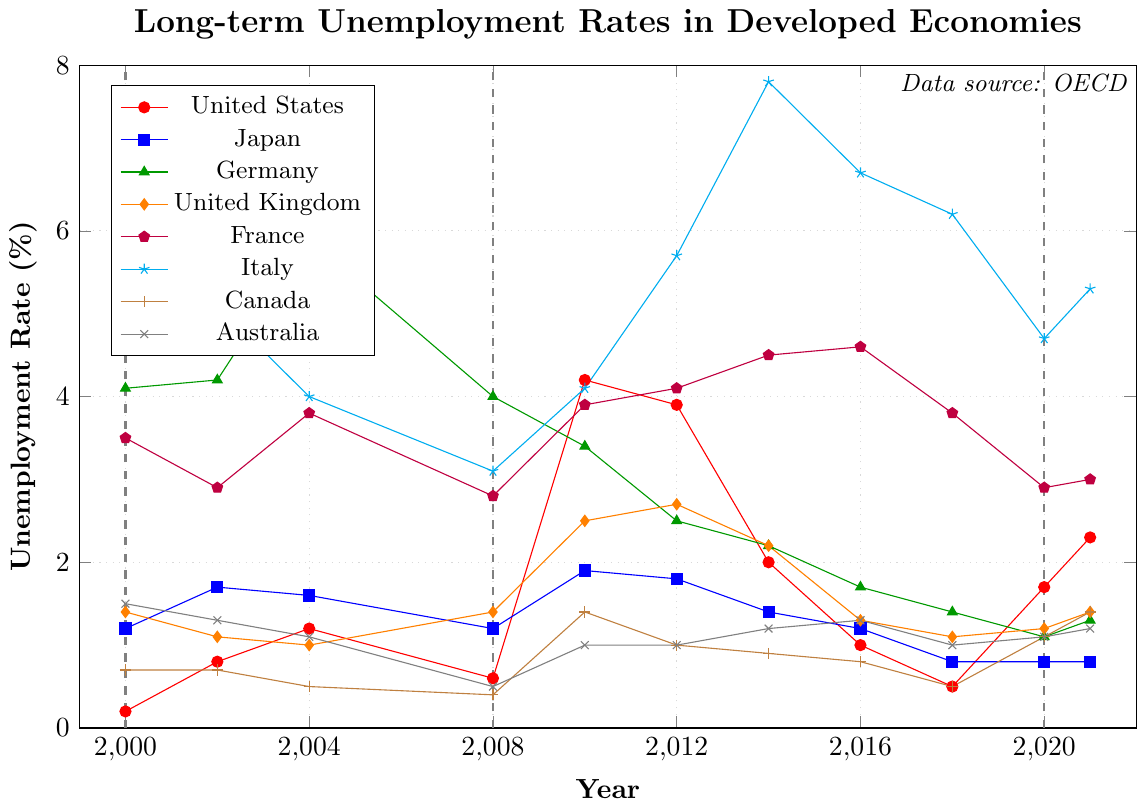Which country had the highest long-term unemployment rate in 2000? Find the highest value for the year 2000 and identify the corresponding country from the figure. Italy had the highest rate with 6.3%.
Answer: Italy What was the difference in long-term unemployment rates between Germany and Japan in 2004? Germany had a rate of 5.9% and Japan had a rate of 1.6% in 2004. Subtract Japan's rate from Germany's. 5.9% - 1.6% = 4.3%
Answer: 4.3% How did the long-term unemployment rate in the United States change from 2008 to 2010? The rate increased from 0.6% in 2008 to 4.2% in 2010. The change is 4.2% - 0.6% = 3.6%.
Answer: Increased by 3.6% Between 2008 and 2012, which country saw the largest absolute increase in long-term unemployment rate? Calculate the difference between 2012 and 2008 rates for each country. Italy had the largest increase: 5.7% (2012) - 3.1% (2008) = 2.6%.
Answer: Italy Which two countries had nearly equal long-term unemployment rates in 2021? United States at 2.3% and France at 3.0% both had similar rates around 2-3%. Identify the closest pairs.
Answer: United States and France How did the long-term unemployment rate in France change from 2008 to 2014? The rate increased from 2.8% in 2008 to 4.5% in 2014. Calculate the change, 4.5% - 2.8% = 1.7%.
Answer: Increased by 1.7% Which country experienced a decrease in long-term unemployment rate from 2012 to 2016? Check the rates of each country in both years and find the one that decreased. Germany decreased from 2.5% to 1.7%.
Answer: Germany What is the average long-term unemployment rate for Canada from 2010 to 2016? The rates are 1.4%, 1.0%, 0.9%, and 0.8%. Calculate the average: (1.4 + 1.0 + 0.9 + 0.8) / 4 = 1.03%.
Answer: 1.03% During which economic crisis did the long-term unemployment rate in Italy peak? Identify the peak in Italy's long-term unemployment rate and align it with the economic crises marked. The peak was 7.8% in 2014 after the 2008 financial crisis.
Answer: 2008 financial crisis 